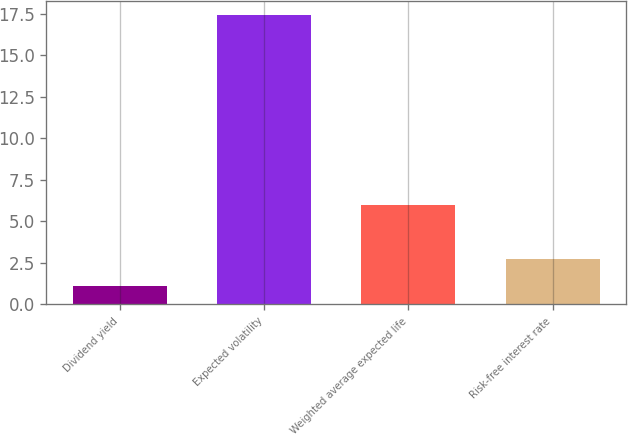Convert chart to OTSL. <chart><loc_0><loc_0><loc_500><loc_500><bar_chart><fcel>Dividend yield<fcel>Expected volatility<fcel>Weighted average expected life<fcel>Risk-free interest rate<nl><fcel>1.1<fcel>17.4<fcel>6<fcel>2.73<nl></chart> 